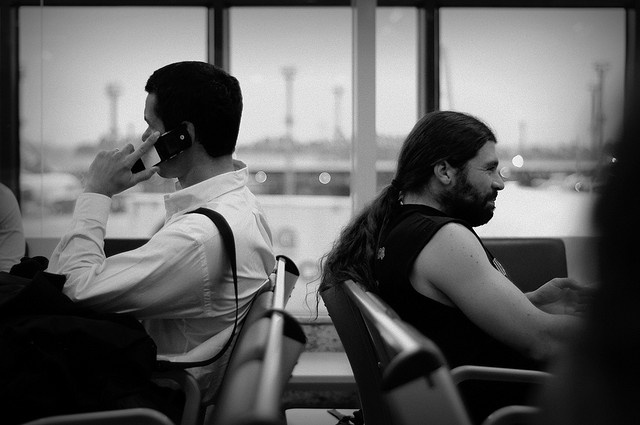Describe the objects in this image and their specific colors. I can see people in black, darkgray, gray, and lightgray tones, people in black, gray, darkgray, and lightgray tones, handbag in black and gray tones, chair in black, gray, darkgray, and lightgray tones, and bench in black, gray, darkgray, and lightgray tones in this image. 